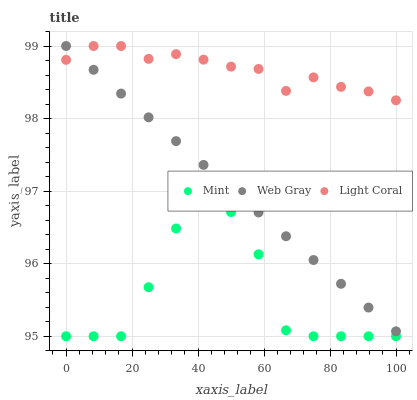Does Mint have the minimum area under the curve?
Answer yes or no. Yes. Does Light Coral have the maximum area under the curve?
Answer yes or no. Yes. Does Web Gray have the minimum area under the curve?
Answer yes or no. No. Does Web Gray have the maximum area under the curve?
Answer yes or no. No. Is Web Gray the smoothest?
Answer yes or no. Yes. Is Mint the roughest?
Answer yes or no. Yes. Is Mint the smoothest?
Answer yes or no. No. Is Web Gray the roughest?
Answer yes or no. No. Does Mint have the lowest value?
Answer yes or no. Yes. Does Web Gray have the lowest value?
Answer yes or no. No. Does Web Gray have the highest value?
Answer yes or no. Yes. Does Mint have the highest value?
Answer yes or no. No. Is Mint less than Light Coral?
Answer yes or no. Yes. Is Light Coral greater than Mint?
Answer yes or no. Yes. Does Light Coral intersect Web Gray?
Answer yes or no. Yes. Is Light Coral less than Web Gray?
Answer yes or no. No. Is Light Coral greater than Web Gray?
Answer yes or no. No. Does Mint intersect Light Coral?
Answer yes or no. No. 